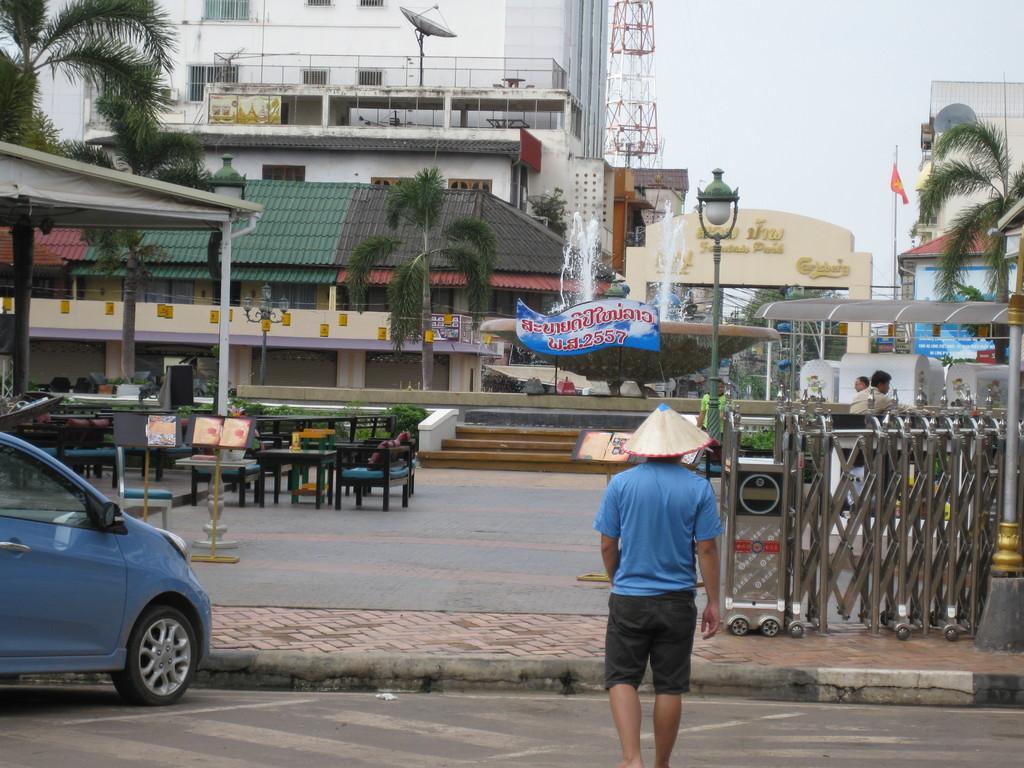How would you summarize this image in a sentence or two? In this image there is a man who is walking on the road and there is a side walk in front of him. In t he background there are buildings,towers,fountain,dish tv,pole,arch. To the left side there is car which is parked on the road and also there are tables and chairs. In front of man there is a big hoarding. 